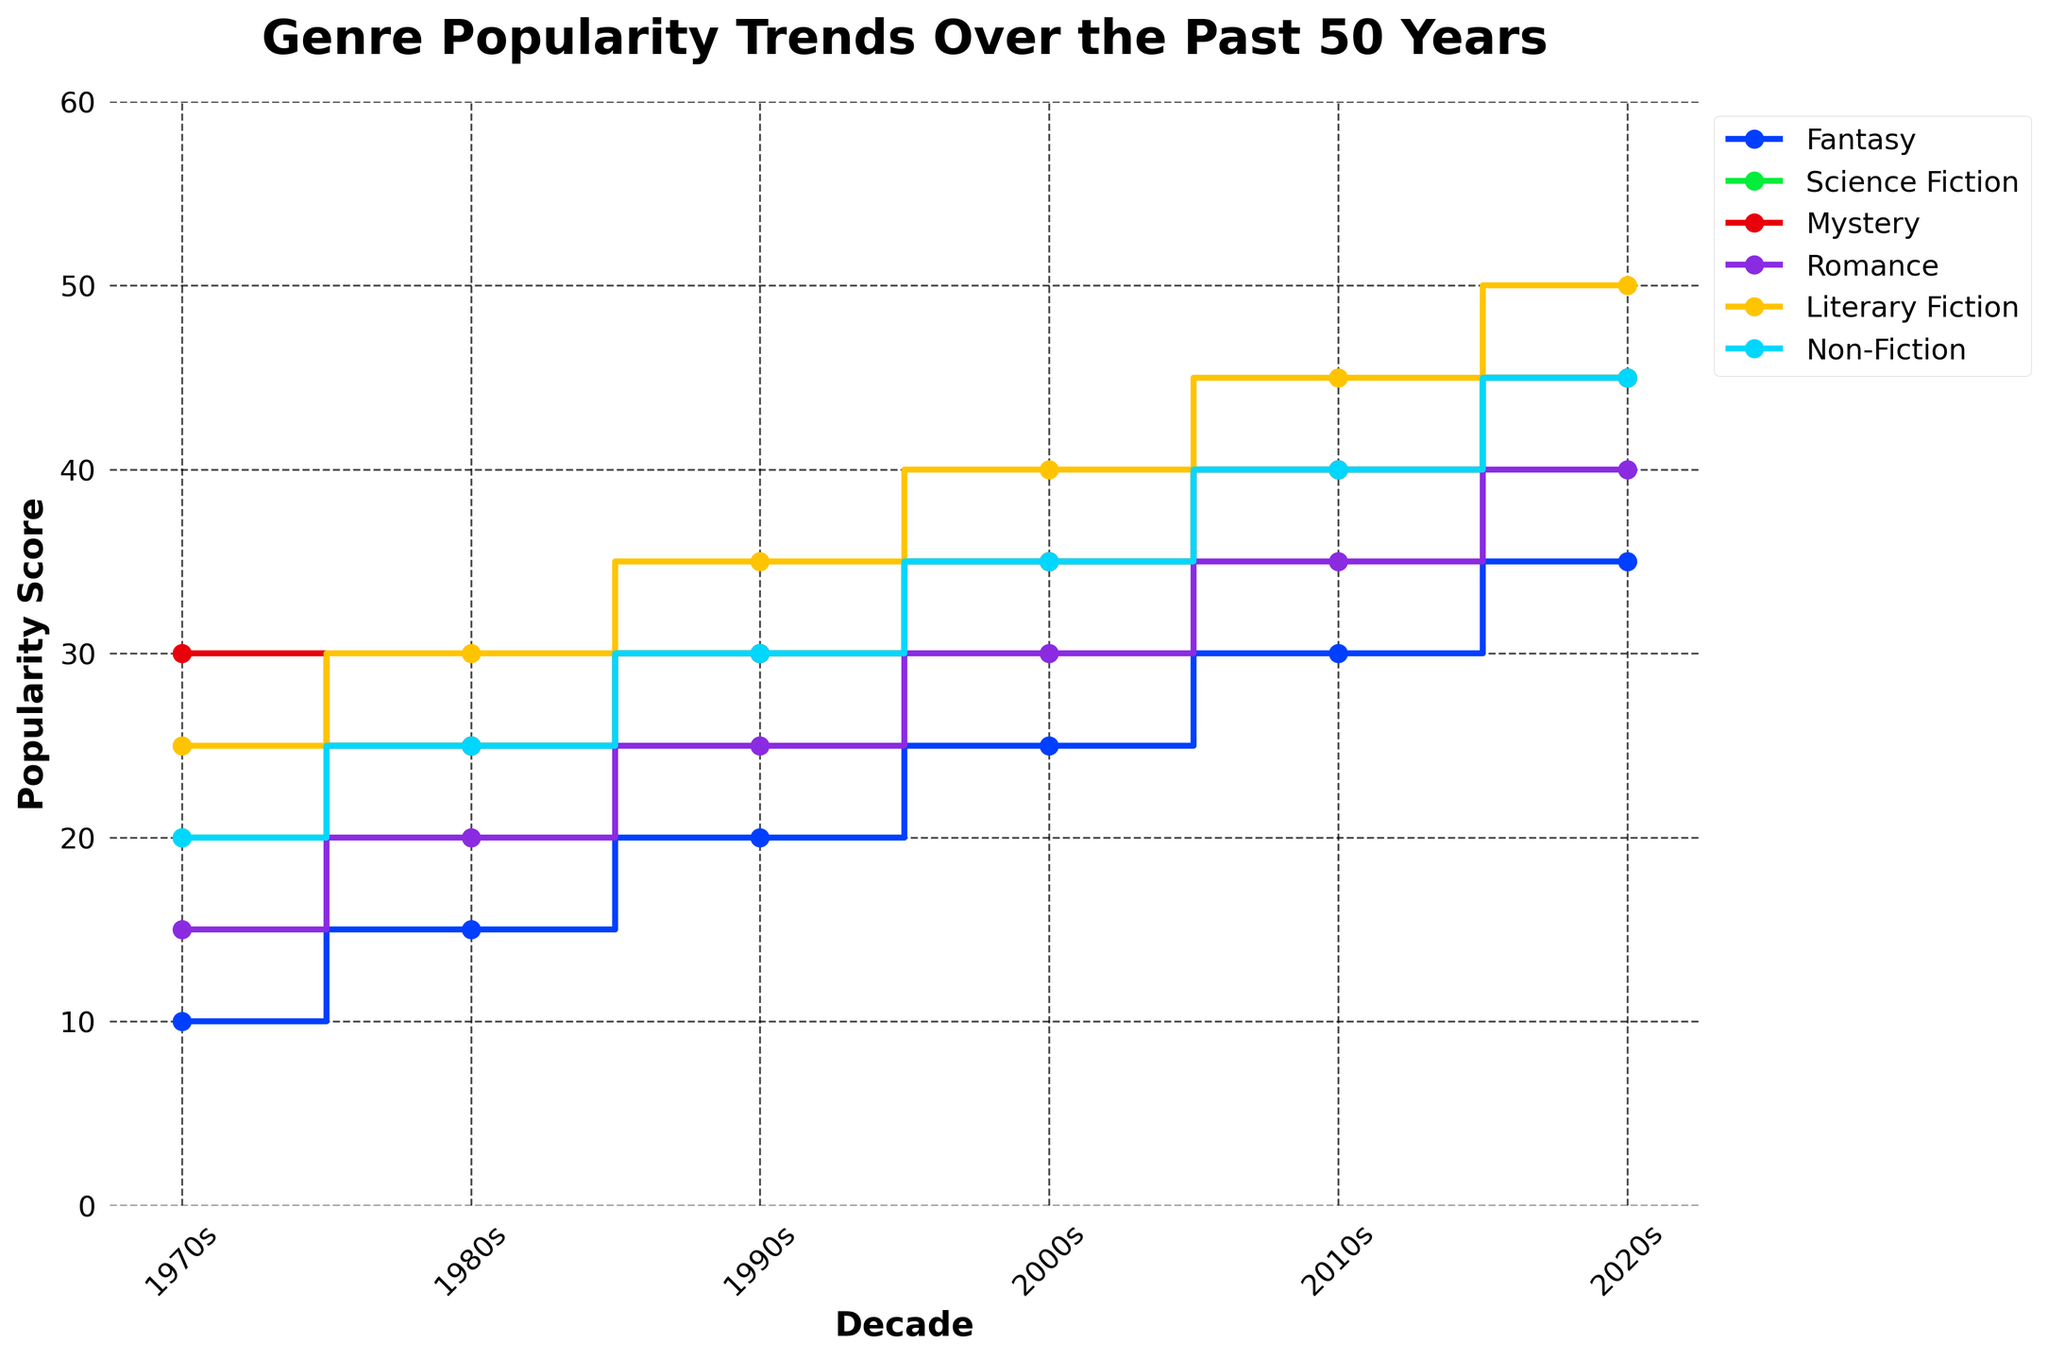What's the title of the plot? The title is mentioned at the top of the figure in bold and larger font size. It reads "Genre Popularity Trends Over the Past 50 Years".
Answer: Genre Popularity Trends Over the Past 50 Years Which genre consistently shows an increase in popularity every decade? By examining the stair plot, we can observe that the popularity scores for "Fantasy" increase in every decade from the 1970s to the 2020s.
Answer: Fantasy Which decade saw the highest popularity score for Non-Fiction? From the stair plot, we can see the trend for Non-Fiction. The highest point on the Non-Fiction line is in the 2020s.
Answer: 2020s How much did the popularity of Mystery change from the 1970s to the 2020s? The popularity score for Mystery in the 1970s was 30, and it rose to 45 in the 2020s. The change is calculated by subtracting the 1970s value from the 2020s value: 45 - 30 = 15.
Answer: 15 Which genre had the lowest popularity score in the 2000s? Referring to the 2000s points on the stair plot for each genre, Romance has the lowest score, which is 30.
Answer: Romance Between which decades did Science Fiction experience the greatest increase in popularity? By comparing the increment between decades on the stair plot for Science Fiction, the greatest increase is between the 2010s and 2020s, where it rose by 5 points from 40 to 45.
Answer: 2010s to 2020s What genre had a popularity score of 25 in the 1980s? By examining each genre's score in the 1980s, we see that Mystery had a popularity score of 25.
Answer: Mystery What is the trend in popularity for Literary Fiction over the 50 years period? The stair plot shows that the popularity of Literary Fiction increases steadily each decade, starting from 25 in the 1970s to 50 in the 2020s.
Answer: Steadily increasing Which two genres had the same popularity score in the 1990s? By looking at the 1990s data points on the plot, both Mystery and Science Fiction have a score of 30.
Answer: Mystery and Science Fiction What is the increase in popularity of Romance from the 1970s to the 2010s? The popularity of Romance in the 1970s was 15, which increased to 35 in the 2010s. Subtracting the earlier value from the later value gives: 35 - 15 = 20.
Answer: 20 